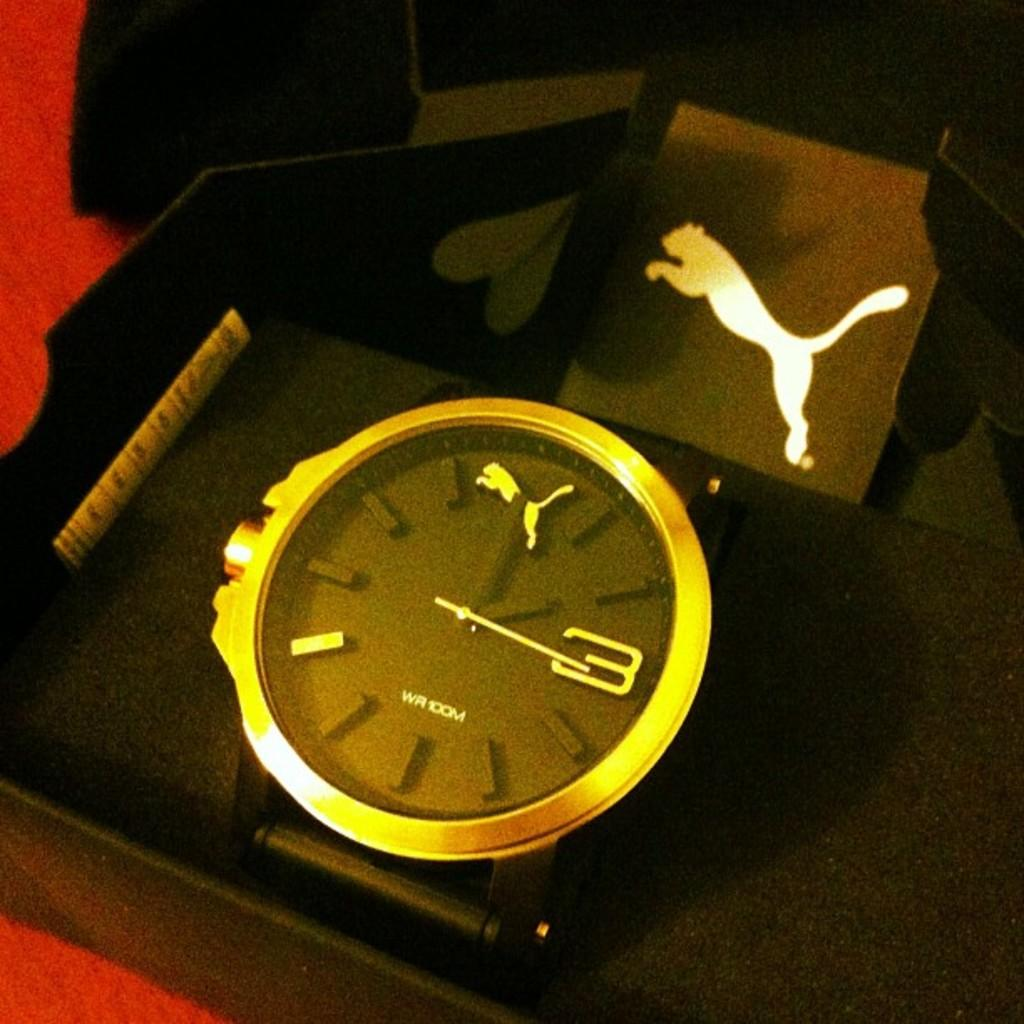What is the main object in the image? There is a black box in the image. What is inside the black box? The black box contains a wrist watch. Where is the black box placed? The black box is placed on a table. What color is the table sheet? The table is covered with a red color sheet. What can be seen in the background of the image? The background of the image is black in color. How much does the van cost in the image? There is no van present in the image, so it is not possible to determine its price. 